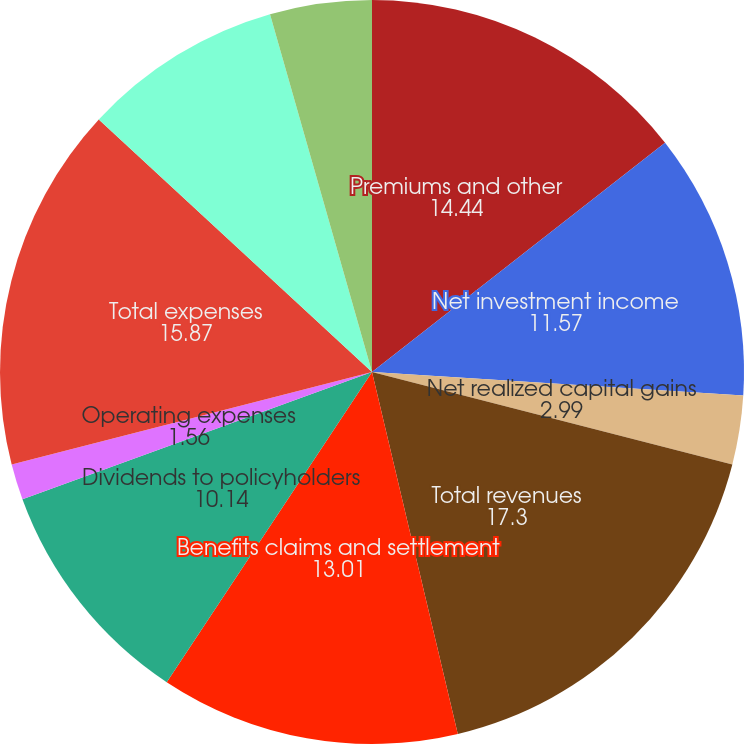Convert chart to OTSL. <chart><loc_0><loc_0><loc_500><loc_500><pie_chart><fcel>Premiums and other<fcel>Net investment income<fcel>Net realized capital gains<fcel>Total revenues<fcel>Benefits claims and settlement<fcel>Dividends to policyholders<fcel>Operating expenses<fcel>Total expenses<fcel>Closed Block revenues net of<fcel>Income taxes<nl><fcel>14.44%<fcel>11.57%<fcel>2.99%<fcel>17.3%<fcel>13.01%<fcel>10.14%<fcel>1.56%<fcel>15.87%<fcel>8.71%<fcel>4.42%<nl></chart> 